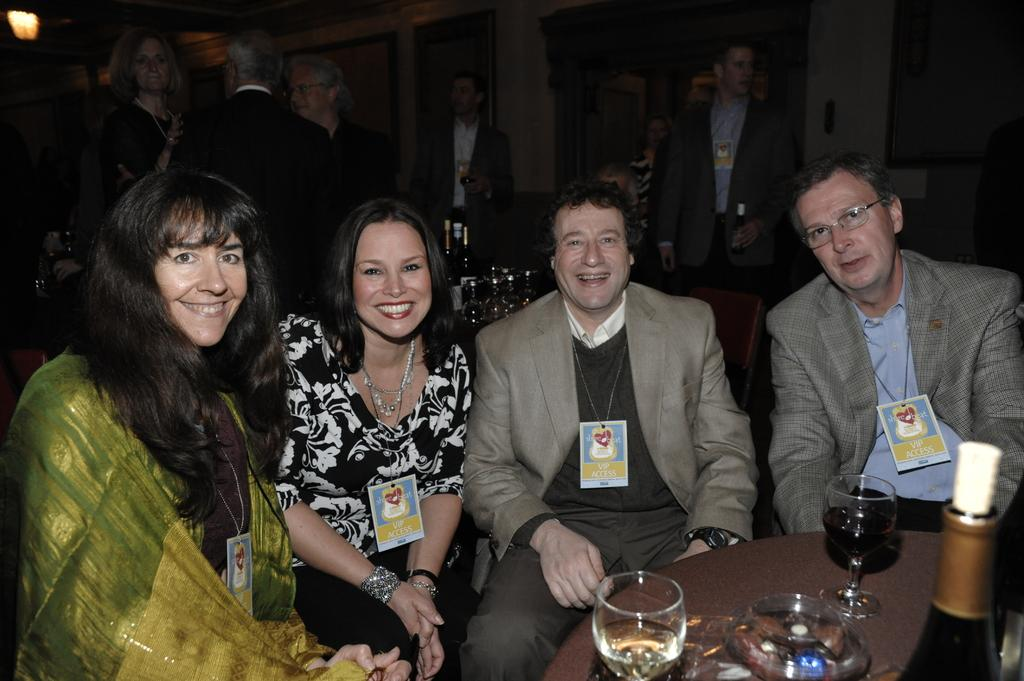What are the people in the image doing? There are people sitting and standing in the image. What objects are on the table in the image? There are glasses filled with liquid and bottles on the table in the image. What type of beds can be seen in the image? There are no beds present in the image. What joke is being told by the people in the image? There is no indication of a joke being told in the image. 